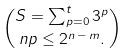<formula> <loc_0><loc_0><loc_500><loc_500>S = \sum _ { p = 0 } ^ { t } 3 ^ { p } \choose { n } { p } \leq 2 ^ { n \, - \, m } .</formula> 